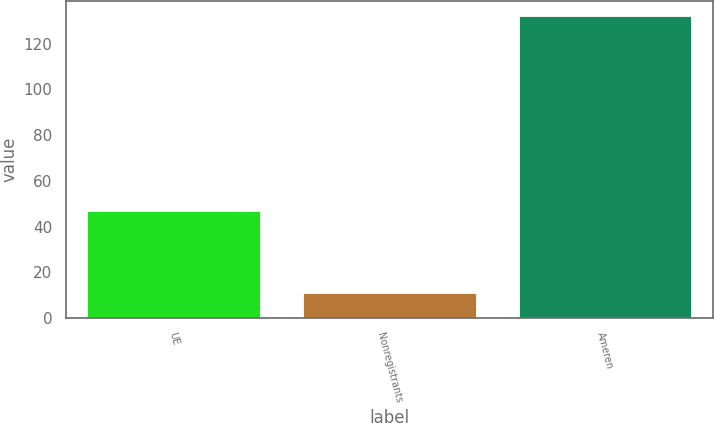<chart> <loc_0><loc_0><loc_500><loc_500><bar_chart><fcel>UE<fcel>Nonregistrants<fcel>Ameren<nl><fcel>47<fcel>11<fcel>132<nl></chart> 